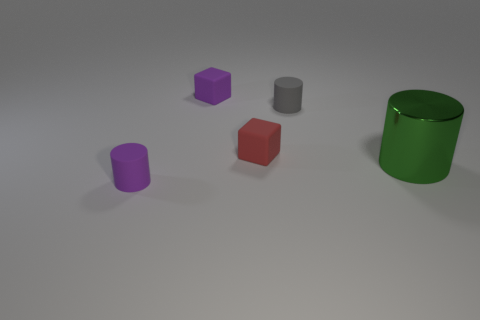Add 3 blocks. How many objects exist? 8 Subtract all cubes. How many objects are left? 3 Subtract all red shiny cylinders. Subtract all small gray cylinders. How many objects are left? 4 Add 4 rubber cylinders. How many rubber cylinders are left? 6 Add 5 purple cylinders. How many purple cylinders exist? 6 Subtract 0 red cylinders. How many objects are left? 5 